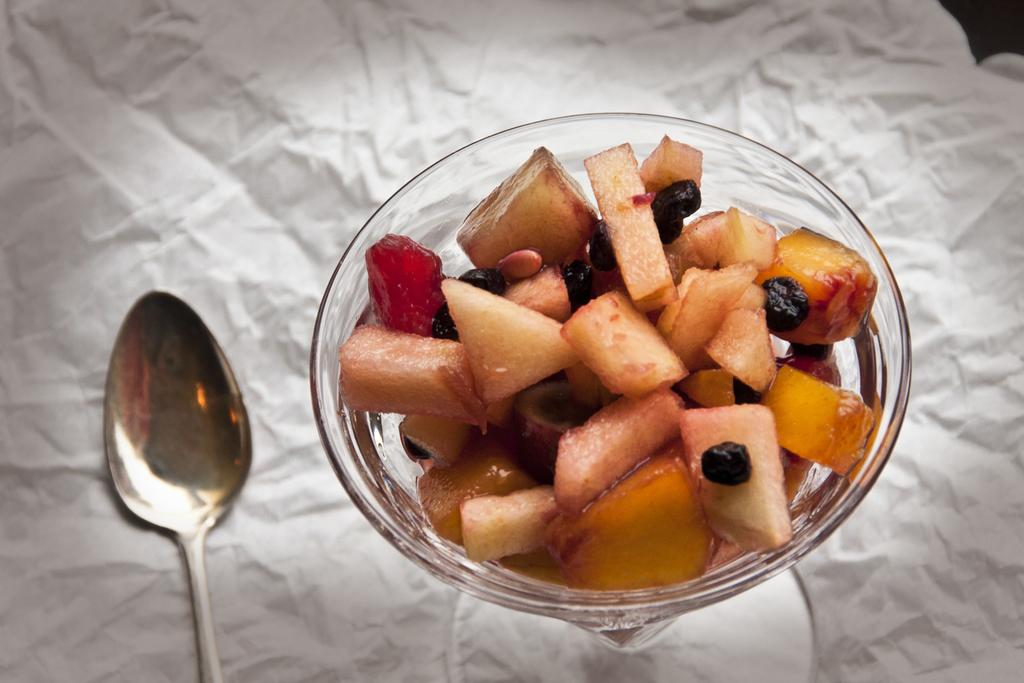What is the main subject of the image? The main subject of the image is a group of fruits. How are the fruits arranged in the image? The fruits are placed in a bowl. Where is the bowl located in the image? The bowl is kept on a table. What utensil can be seen in the image? There is a spoon to the left side of the image. How many ladybugs are crawling on the fruits in the image? There are no ladybugs present in the image; it only features a group of fruits in a bowl on a table. 